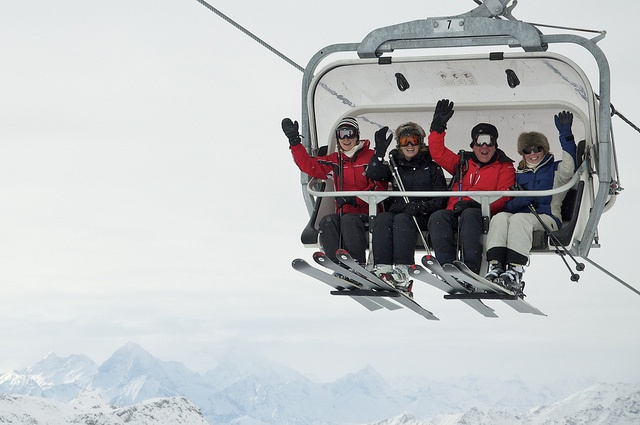Describe the objects in this image and their specific colors. I can see people in lightgray, darkgray, black, gray, and navy tones, people in lightgray, black, brown, darkgray, and maroon tones, people in lightgray, black, gray, and darkgray tones, people in lightgray, black, maroon, brown, and gray tones, and skis in lightgray, gray, and black tones in this image. 